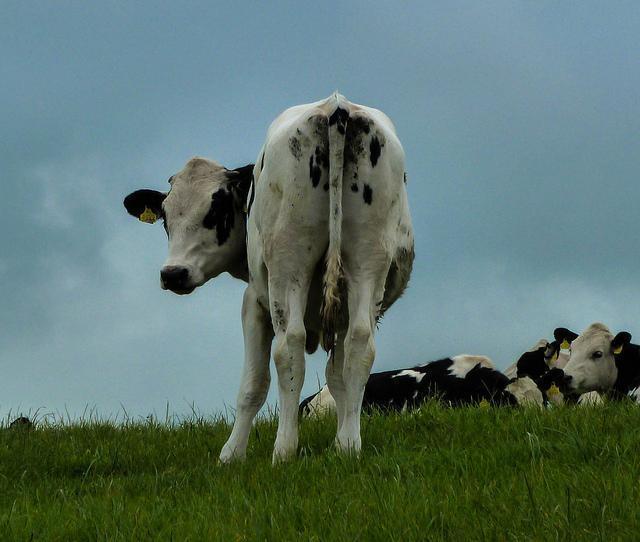How many cows can be seen?
Give a very brief answer. 3. 